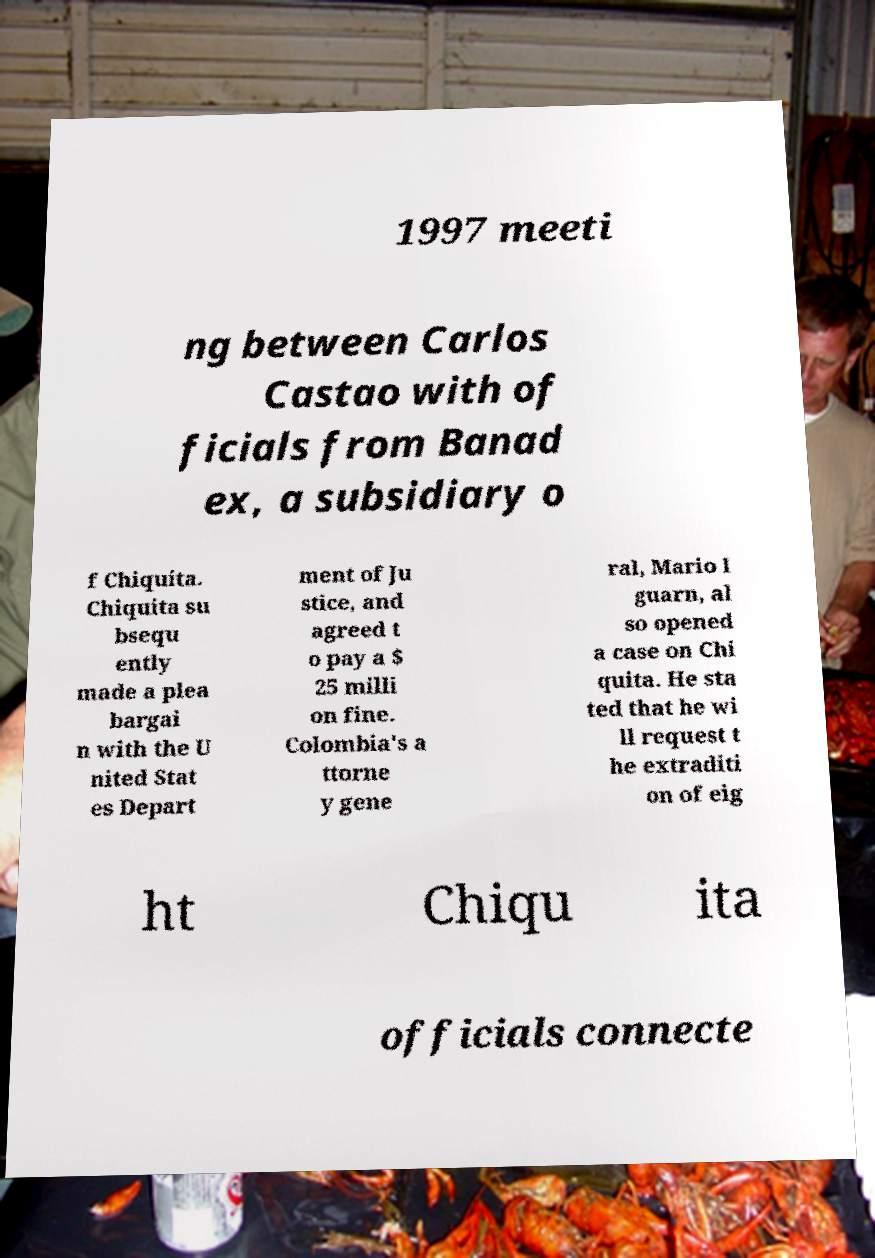Please read and relay the text visible in this image. What does it say? 1997 meeti ng between Carlos Castao with of ficials from Banad ex, a subsidiary o f Chiquita. Chiquita su bsequ ently made a plea bargai n with the U nited Stat es Depart ment of Ju stice, and agreed t o pay a $ 25 milli on fine. Colombia's a ttorne y gene ral, Mario I guarn, al so opened a case on Chi quita. He sta ted that he wi ll request t he extraditi on of eig ht Chiqu ita officials connecte 